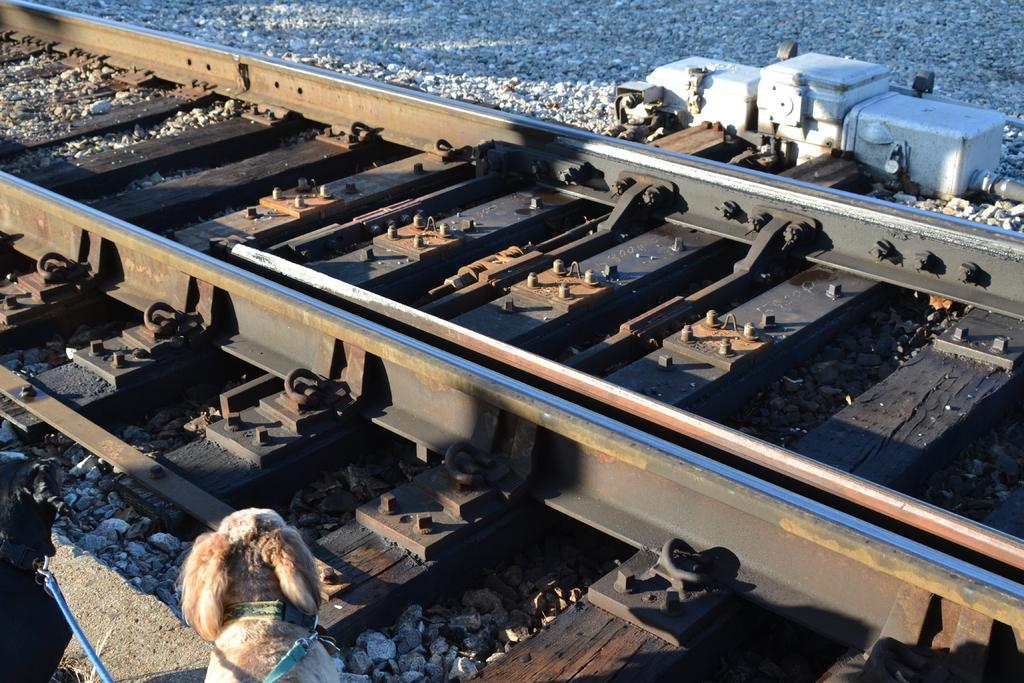Could you give a brief overview of what you see in this image? In this image I can see the track. To the side of the track I can see the dogs which are in black and brown color. In the background I can see many stones. 